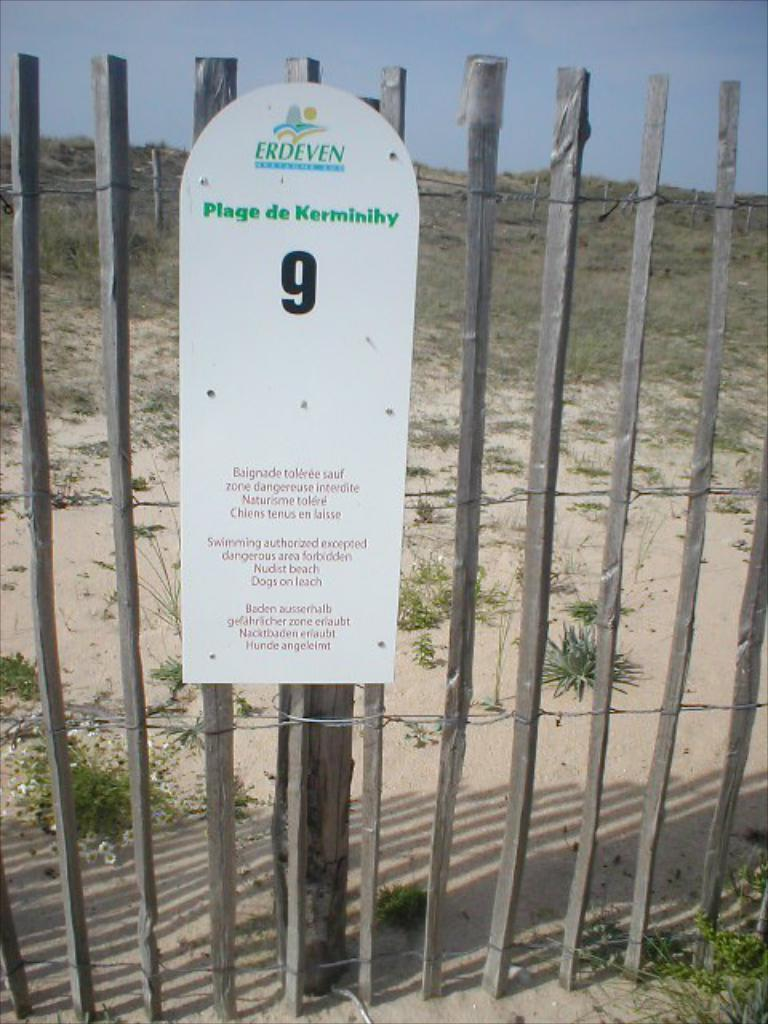What is present in the image that separates or encloses an area? There is a fence in the image. What is attached to the fence? There is a board on the fence. What can be seen in the background of the image? There are plants and poles in the background of the image. What is visible in the sky in the image? The sky is visible in the background of the image. How many oranges are hanging from the fence in the image? There are no oranges present in the image. What type of organization is responsible for maintaining the fence in the image? There is no information about an organization responsible for maintaining the fence in the image. 